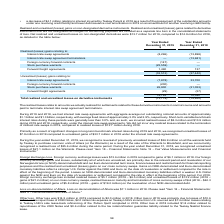According to Teekay Corporation's financial document, What was the Net realized and unrealized losses on non-designated derivatives in 2019? According to the financial document, $13.7 million. The relevant text states: "realized losses on non-designated derivatives were $13.7 million for 2019, compared to $14.9 million for 2018, as detailed in the table below:..." Also, What was the Net realized and unrealized losses on non-designated derivatives in 2018? According to the financial document, $14.9 million. The relevant text states: "rivatives were $13.7 million for 2019, compared to $14.9 million for 2018, as detailed in the table below:..." Also, How much was the interest rate swap agreements with aggregate average net outstanding notional amounts during 2019 and 2018 respectively? The document shows two values: $1.1 billion and $1.3 billion. From the document: "net outstanding notional amounts of approximately $1.1 billion and $1.3 billion, respectively, with average fixed rates of approximately 3.0% and 2.9%..." Also, can you calculate: What is the change in Realized (losses) gains relating to Interest rate swap agreements from Year Ended December 31, 2019 to December 31, 2018? Based on the calculation: 8,296-13,898, the result is -5602 (in thousands). This is based on the information: "Interest rate swap agreements (8,296) (13,898) Interest rate swap agreements (8,296) (13,898)..." The key data points involved are: 13,898, 8,296. Also, can you calculate: What is the change in Realized (losses) gains relating to Forward freight agreements from Year Ended December 31, 2019 to December 31, 2018? Based on the calculation: 1,490-137, the result is 1353 (in thousands). This is based on the information: "Forward freight agreements 1,490 137 Forward freight agreements 1,490 137..." The key data points involved are: 1,490, 137. Also, can you calculate: What is the change in Unrealized (losses) gains relating to Interest rate swap agreements from Year Ended December 31, 2019 to December 31, 2018? Based on the calculation: -7,878-33,700, the result is -41578 (in thousands). This is based on the information: "Interest rate swap agreements (7,878) 33,700 Interest rate swap agreements (7,878) 33,700..." The key data points involved are: 33,700, 7,878. 